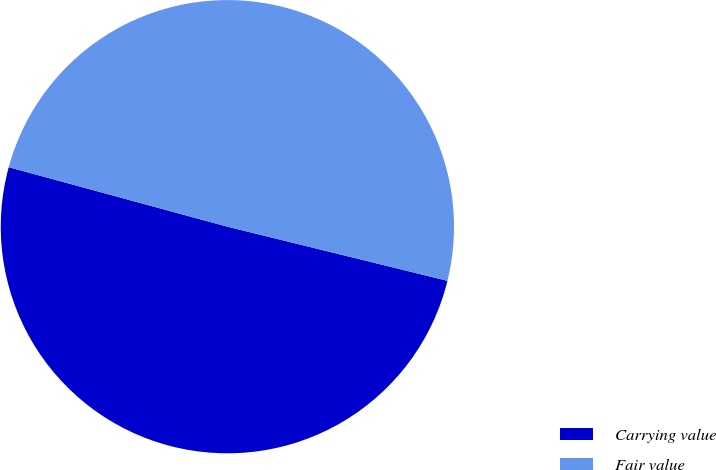<chart> <loc_0><loc_0><loc_500><loc_500><pie_chart><fcel>Carrying value<fcel>Fair value<nl><fcel>50.39%<fcel>49.61%<nl></chart> 